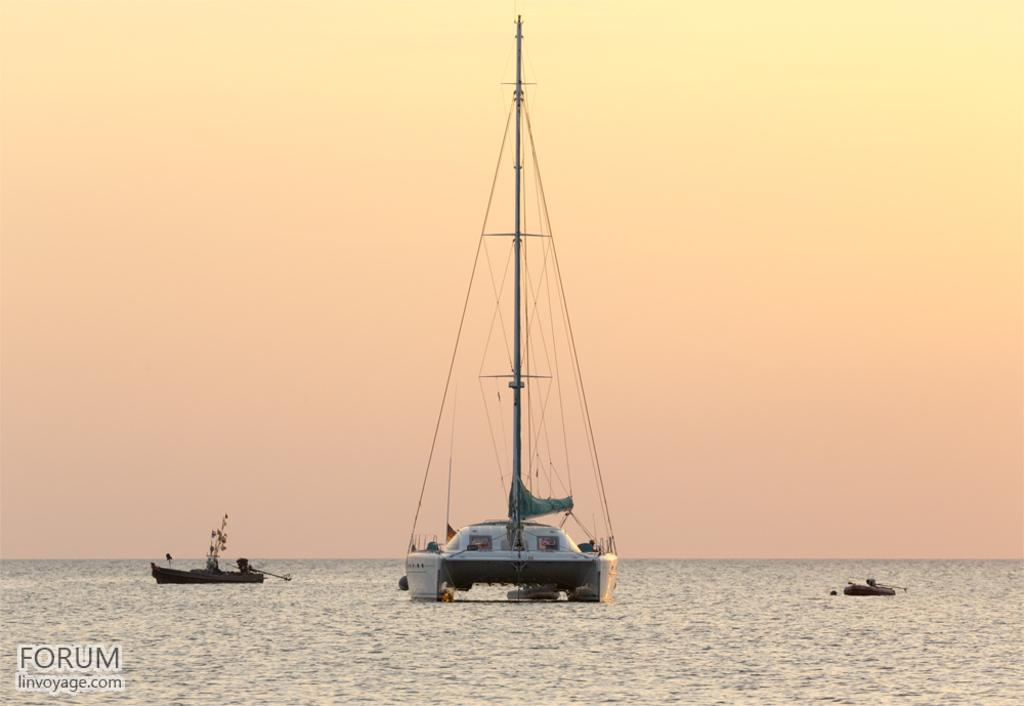What type of vehicles can be seen in the image? There are boats in the image. Where are the boats located? The boats are present in a river. What natural element is visible in the image? There is water visible in the image. What type of park can be seen in the image? There is no park present in the image; it features boats in a river. What type of stamp is visible on the boats in the image? There are no stamps visible on the boats in the image. 